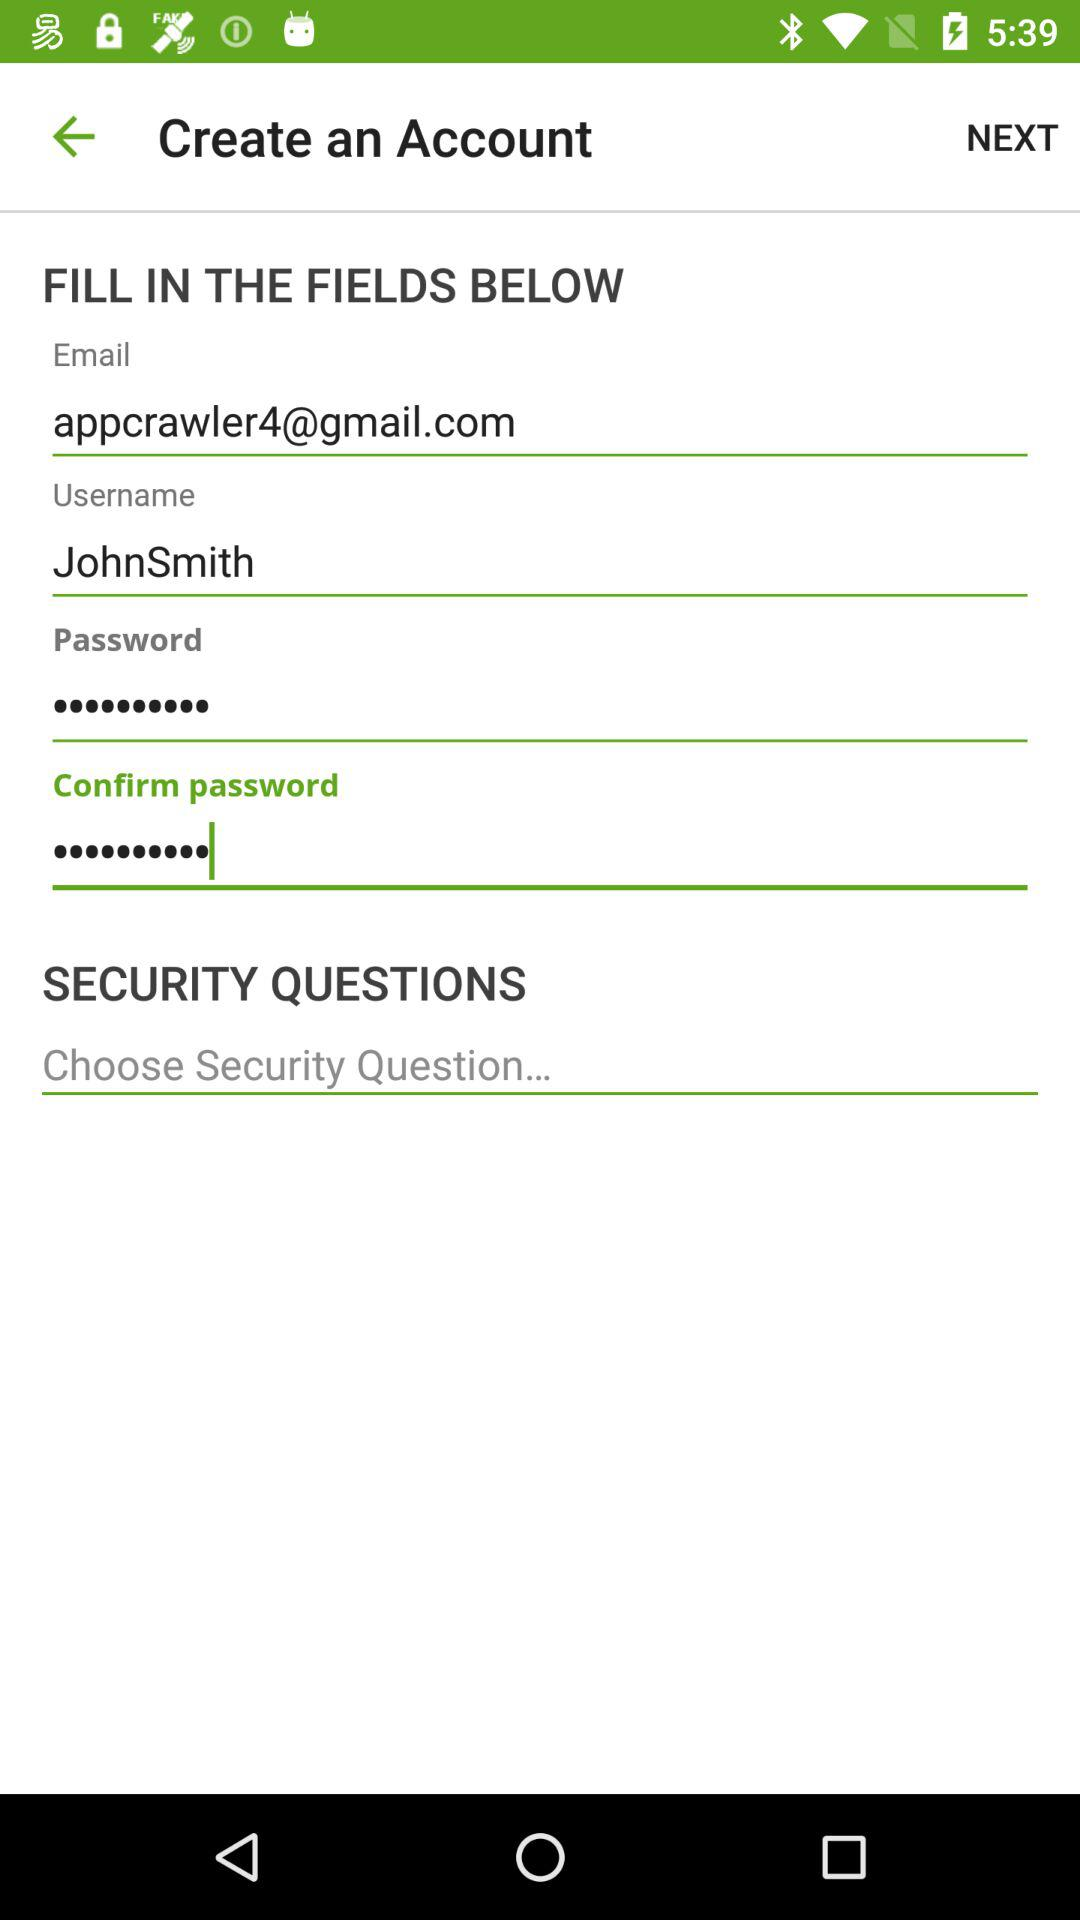What is the email address? The email address is appcrawler4@gmail.com. 